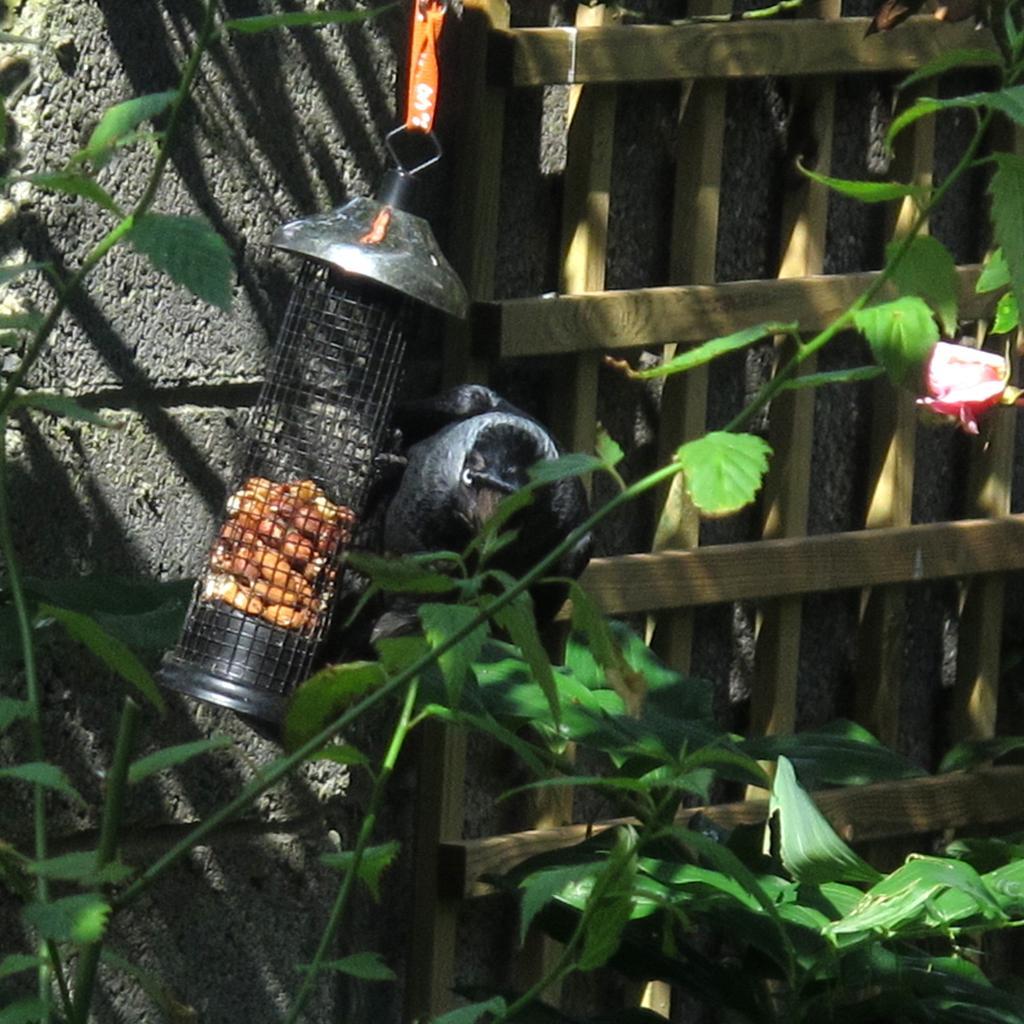Can you describe this image briefly? In this image we can see a bird, black color object looks like a jar and a few objects in it, there are few plants and in the background there is a wall and a wooden object looks like a gate. 